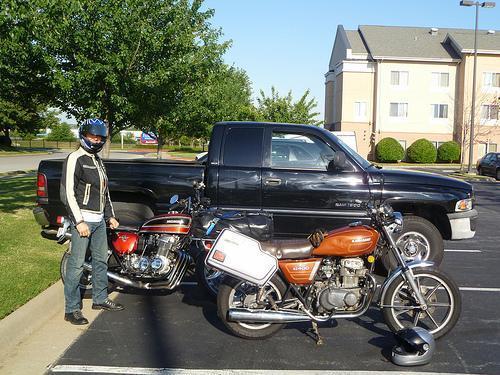How many people in the photo?
Give a very brief answer. 1. How many bikes are in the parking lot?
Give a very brief answer. 2. How many bushes are there by the buildings?
Give a very brief answer. 3. 